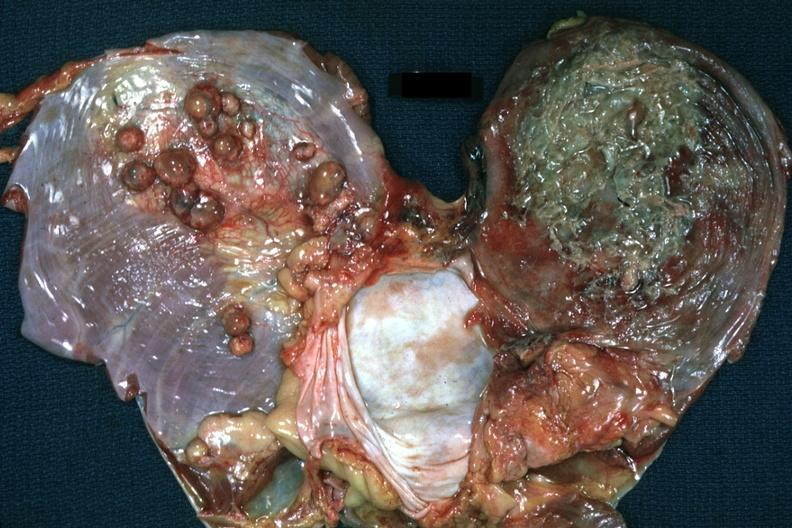s muscle present?
Answer the question using a single word or phrase. Yes 